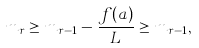<formula> <loc_0><loc_0><loc_500><loc_500>m _ { r } \geq m _ { r - 1 } - \frac { f ( a ) } { L } \geq m _ { r - 1 } ,</formula> 